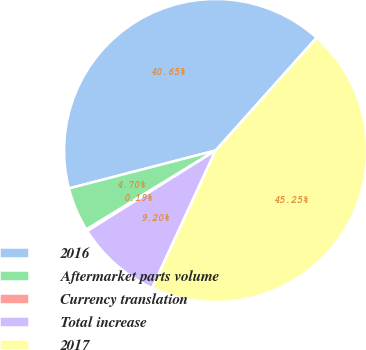<chart> <loc_0><loc_0><loc_500><loc_500><pie_chart><fcel>2016<fcel>Aftermarket parts volume<fcel>Currency translation<fcel>Total increase<fcel>2017<nl><fcel>40.65%<fcel>4.7%<fcel>0.19%<fcel>9.2%<fcel>45.25%<nl></chart> 